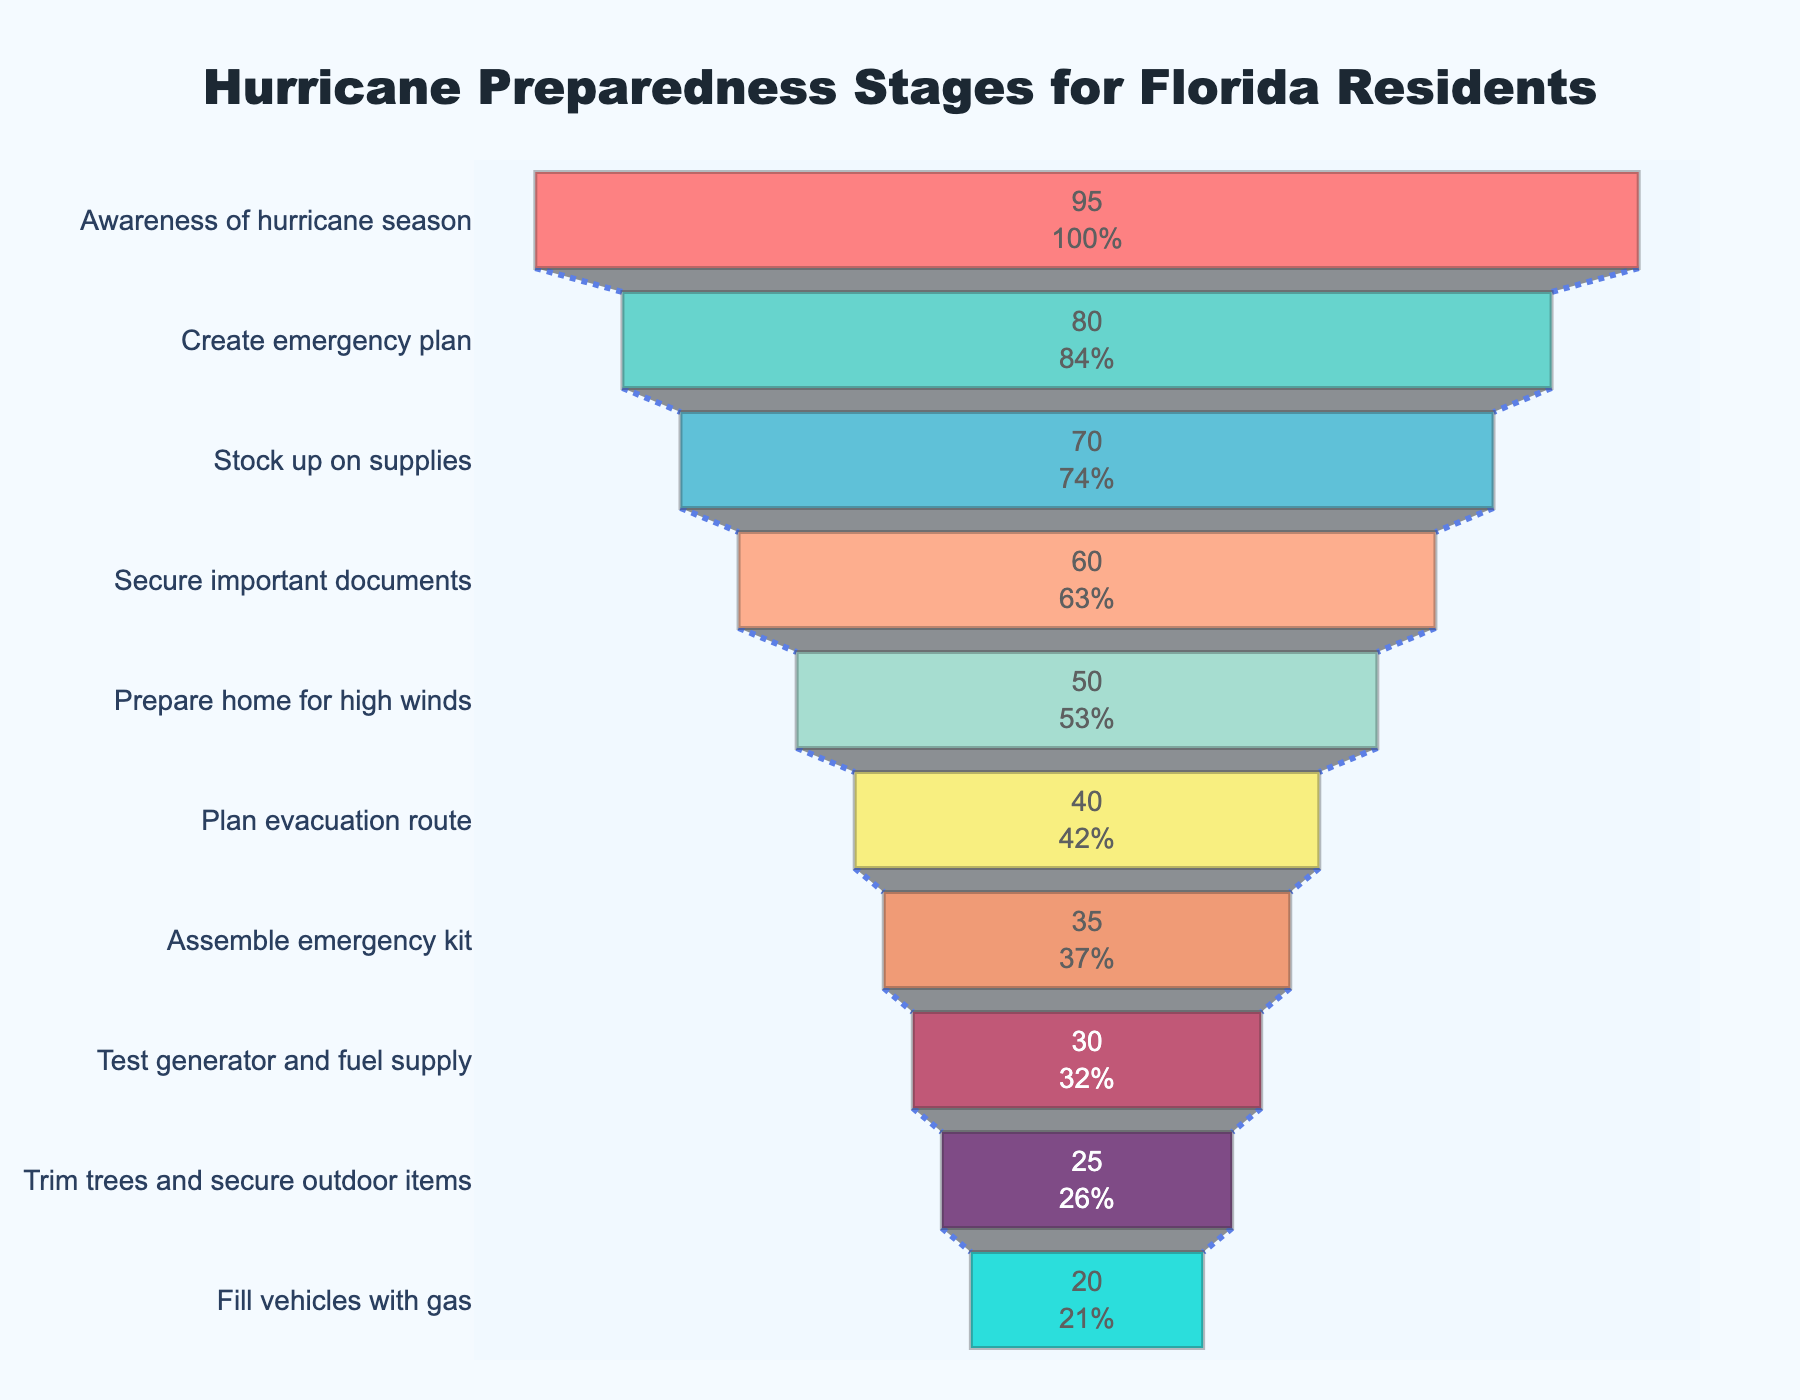What is the title of the funnel chart? The title of the funnel chart is located at the top center of the figure. It reads "Hurricane Preparedness Stages for Florida Residents."
Answer: Hurricane Preparedness Stages for Florida Residents How many stages of hurricane preparedness are depicted in the funnel chart? You can count the number of distinct stages marked on the y-axis of the chart. There are 10 stages listed from "Awareness of hurricane season" to "Fill vehicles with gas."
Answer: 10 Which stage has the highest percentage of completion among Florida residents? The stage with the highest percentage is at the top of the funnel, which is "Awareness of hurricane season." It shows a 95% completion rate.
Answer: Awareness of hurricane season What percentage of residents have created an emergency plan? The specific percentage for "Create emergency plan" is displayed inside the bar for that stage. The percentage shown is 80%.
Answer: 80% Compare the percentages of residents who have stocked up on supplies and those who have an emergency kit. Which is higher? By looking at the stages "Stock up on supplies" and "Assemble emergency kit," you can see their percentages. "Stock up on supplies" has 70%, while "Assemble emergency kit" has 35%. 70% is higher than 35%.
Answer: Stock up on supplies What is the difference in percentage between residents who have prepared their home for high winds and those who have created an emergency plan? "Prepare home for high winds" is at 50% and "Create emergency plan" is at 80%. The difference is 80% - 50% = 30%.
Answer: 30% What's the average percentage of the top three preparedness stages? The top three stages and their percentages are "Awareness of hurricane season" (95%), "Create emergency plan" (80%), and "Stock up on supplies" (70%). The average is (95 + 80 + 70) / 3 = 81.67%.
Answer: 81.67% How many preparedness stages have less than 50% completion? Observing the percentages, the stages with less than 50% completion are "Plan evacuation route" (40%), "Assemble emergency kit" (35%), "Test generator and fuel supply" (30%), "Trim trees and secure outdoor items" (25%), and "Fill vehicles with gas" (20%). There are 5 such stages.
Answer: 5 Which stage shows the closest percentage to the median percentage for all stages? The median percentage for 10 data points is the average of the 5th and 6th highest percentages. The ordered percentages are 95, 80, 70, 60, 50, 40, 35, 30, 25, 20. The median is (50 + 40) / 2 = 45. The stage with the closest percentage to 45% is "Plan evacuation route" with 40%.
Answer: Plan evacuation route 